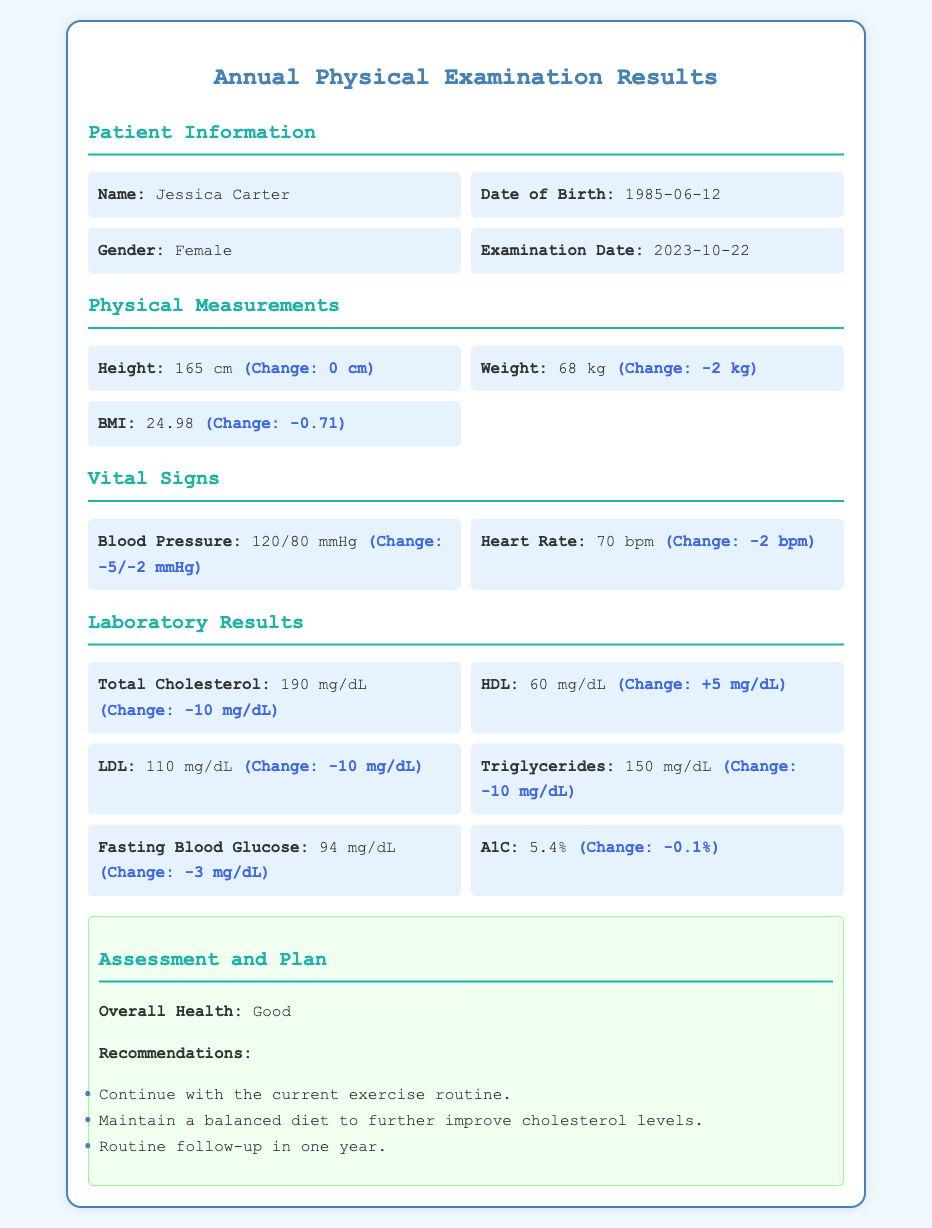What is Jessica Carter's height? Jessica Carter's height is given in the physical measurements section of the document as 165 cm.
Answer: 165 cm What is Jessica Carter's weight? The document lists Jessica Carter's weight as 68 kg in the physical measurements section.
Answer: 68 kg What was Jessica Carter's blood pressure? The blood pressure reading of Jessica Carter is found in the vital signs section and is recorded as 120/80 mmHg.
Answer: 120/80 mmHg What is Jessica Carter's total cholesterol level? In the laboratory results section, the total cholesterol level is mentioned as 190 mg/dL.
Answer: 190 mg/dL What is the change in weight since the last examination? The change in weight for Jessica Carter is noted as -2 kg in the physical measurements section, indicating a decrease.
Answer: -2 kg What is the change in HDL cholesterol? The change in HDL cholesterol is indicated as +5 mg/dL in the laboratory results section, showing an increase.
Answer: +5 mg/dL How often should Jessica follow up according to the assessment? The recommendations in the assessment advise a routine follow-up in one year, indicating the frequency for Jessica Carter.
Answer: one year What is the overall health assessment of Jessica Carter? The overall health assessment for Jessica Carter is stated as "Good" in the assessment section of the document.
Answer: Good What was Jessica's heart rate during the examination? The heart rate recorded for Jessica Carter is found in the vital signs section as 70 bpm.
Answer: 70 bpm 